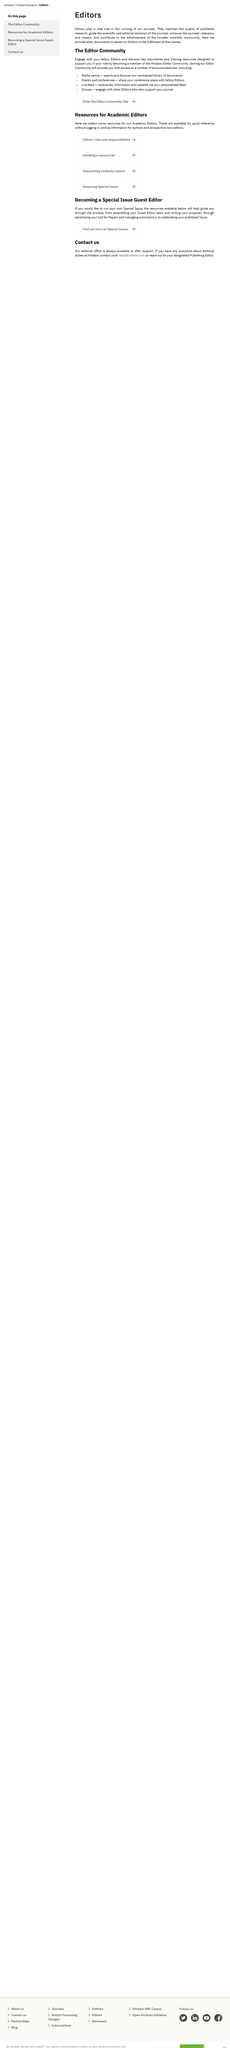Indicate a few pertinent items in this graphic. I can use "Groups" to engage with other Editors who support my journal. Editors play a crucial role in the operation of journals. Our centralized library of documents can be accessed through the Media Centre, where users can search and discover a variety of documents. 